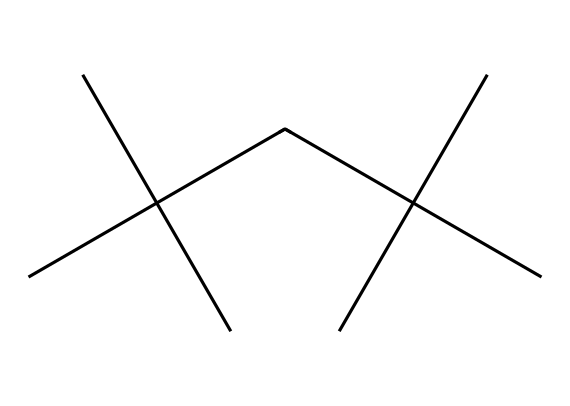What is the main chemical component of this structure? The structure consists primarily of carbon (C) and hydrogen (H) atoms, indicating that the main component is hydrocarbon.
Answer: hydrocarbon How many carbon atoms are present in this molecule? By examining the structure, we can count a total of 12 carbon atoms in the backbone.
Answer: 12 What type of polymer is represented by this structure? The repeating units (monomers) in this structure suggest it is a type of polyethylene, a common thermoplastic polymer made from ethylene.
Answer: polyethylene What is the significance of branching in this polymer structure? The branching in this molecule generally affects properties like density and melting point, leading to lower intermolecular forces compared to linear polymers, thus providing more flexibility.
Answer: flexibility Is this chemical soluble in water? As a non-electrolyte and typical hydrocarbon structure, polyethylene is hydrophobic and does not dissolve in water.
Answer: no What type of intermolecular forces predominates in this polymer? Given the molecular structure, the primary intermolecular forces present would be Van der Waals forces, characteristic of non-polar substances.
Answer: Van der Waals forces What is the typical application of polyethylene in the packaging industry? Polyethylene is widely used for making plastic bags, wraps, and containers due to its durability and chemical resistance.
Answer: plastic bags 